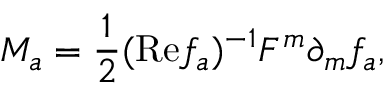Convert formula to latex. <formula><loc_0><loc_0><loc_500><loc_500>M _ { a } = { \frac { 1 } { 2 } } ( R e f _ { a } ) ^ { - 1 } F ^ { m } \partial _ { m } f _ { a } ,</formula> 